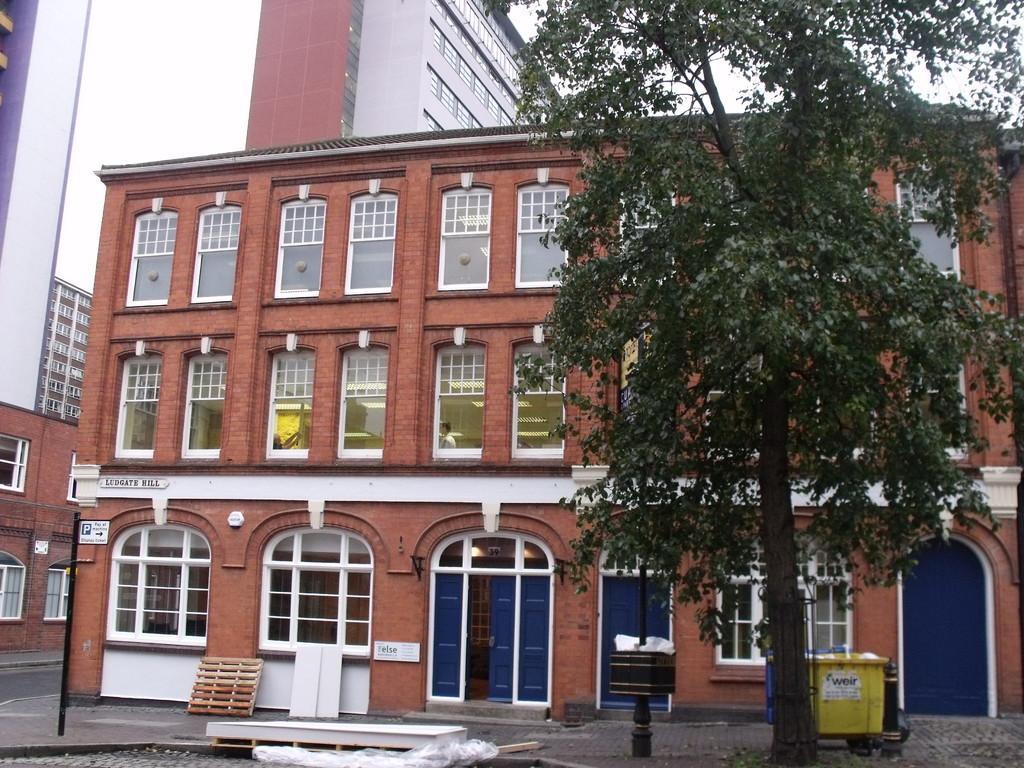Could you give a brief overview of what you see in this image? In this picture we can see buildings, sign board, pole, windows, doors, tree, garbage bins are there. At the bottom of the image ground is there. At the top of the image sky is there. 